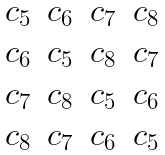Convert formula to latex. <formula><loc_0><loc_0><loc_500><loc_500>\begin{matrix} c _ { 5 } & c _ { 6 } & c _ { 7 } & c _ { 8 } \\ c _ { 6 } & c _ { 5 } & c _ { 8 } & c _ { 7 } \\ c _ { 7 } & c _ { 8 } & c _ { 5 } & c _ { 6 } \\ c _ { 8 } & c _ { 7 } & c _ { 6 } & c _ { 5 } \end{matrix}</formula> 